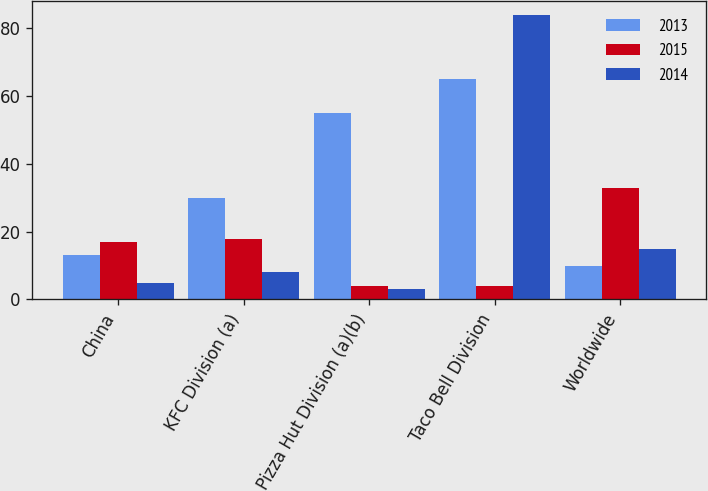Convert chart to OTSL. <chart><loc_0><loc_0><loc_500><loc_500><stacked_bar_chart><ecel><fcel>China<fcel>KFC Division (a)<fcel>Pizza Hut Division (a)(b)<fcel>Taco Bell Division<fcel>Worldwide<nl><fcel>2013<fcel>13<fcel>30<fcel>55<fcel>65<fcel>10<nl><fcel>2015<fcel>17<fcel>18<fcel>4<fcel>4<fcel>33<nl><fcel>2014<fcel>5<fcel>8<fcel>3<fcel>84<fcel>15<nl></chart> 